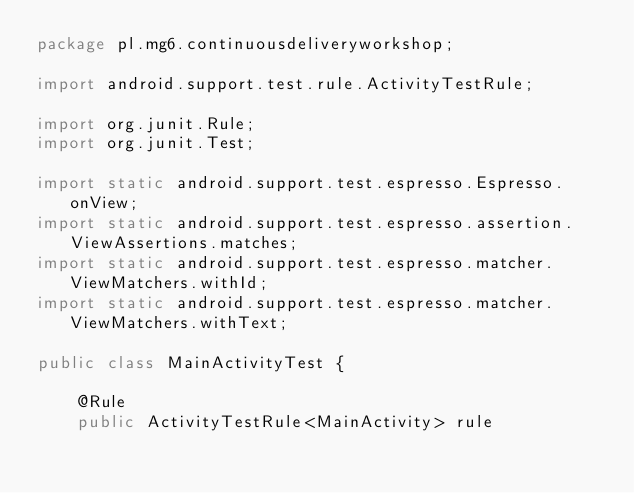<code> <loc_0><loc_0><loc_500><loc_500><_Java_>package pl.mg6.continuousdeliveryworkshop;

import android.support.test.rule.ActivityTestRule;

import org.junit.Rule;
import org.junit.Test;

import static android.support.test.espresso.Espresso.onView;
import static android.support.test.espresso.assertion.ViewAssertions.matches;
import static android.support.test.espresso.matcher.ViewMatchers.withId;
import static android.support.test.espresso.matcher.ViewMatchers.withText;

public class MainActivityTest {

    @Rule
    public ActivityTestRule<MainActivity> rule</code> 